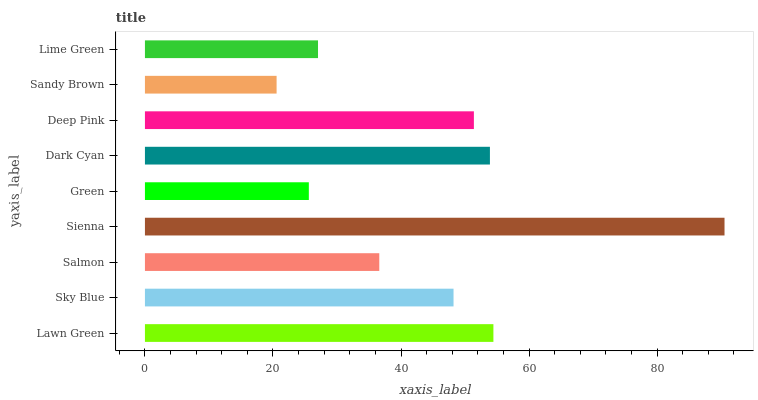Is Sandy Brown the minimum?
Answer yes or no. Yes. Is Sienna the maximum?
Answer yes or no. Yes. Is Sky Blue the minimum?
Answer yes or no. No. Is Sky Blue the maximum?
Answer yes or no. No. Is Lawn Green greater than Sky Blue?
Answer yes or no. Yes. Is Sky Blue less than Lawn Green?
Answer yes or no. Yes. Is Sky Blue greater than Lawn Green?
Answer yes or no. No. Is Lawn Green less than Sky Blue?
Answer yes or no. No. Is Sky Blue the high median?
Answer yes or no. Yes. Is Sky Blue the low median?
Answer yes or no. Yes. Is Salmon the high median?
Answer yes or no. No. Is Salmon the low median?
Answer yes or no. No. 